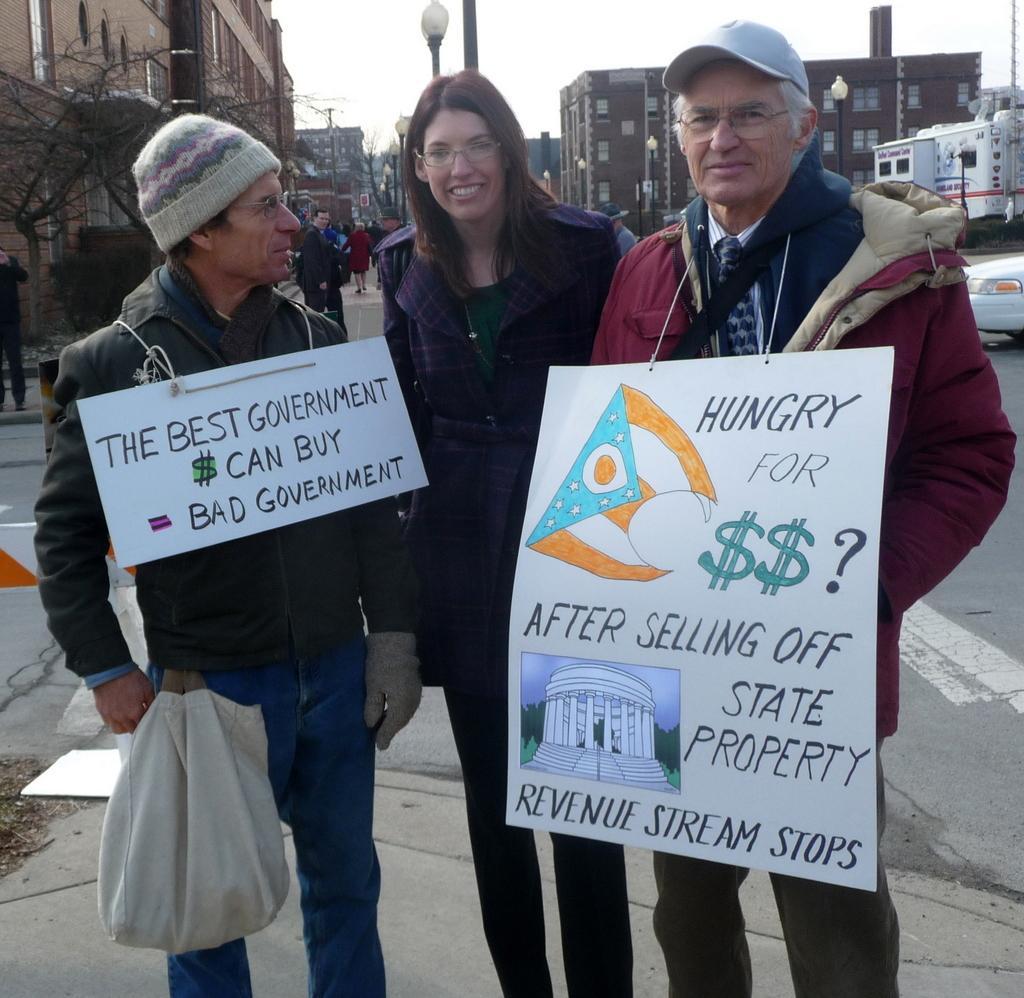Could you give a brief overview of what you see in this image? This picture is clicked outside the city. The man on the right corner of the picture wearing red jacket is wearing a white board with some text written on it. Beside him, a woman in the blue jacket is standing. Beside her, the man in a green jacket is wearing a white board with some text written on it. Behind them, we see people walking on the sideways. There are buildings, trees and street lights in the background. On the right corner of the picture, we see a white car moving on the road. 